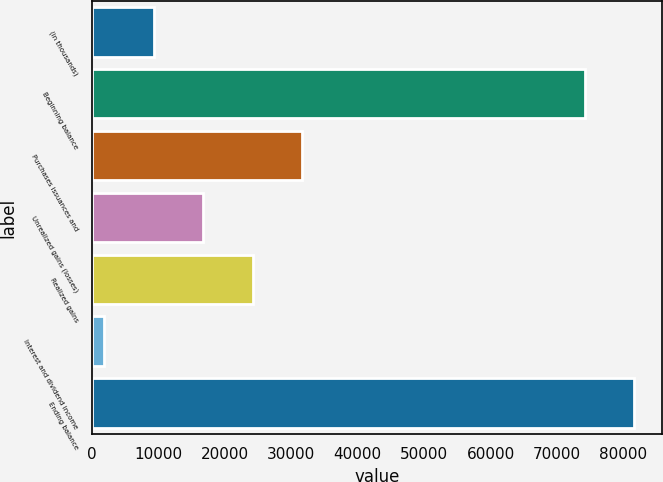Convert chart to OTSL. <chart><loc_0><loc_0><loc_500><loc_500><bar_chart><fcel>(in thousands)<fcel>Beginning balance<fcel>Purchases issuances and<fcel>Unrealized gains (losses)<fcel>Realized gains<fcel>Interest and dividend income<fcel>Ending balance<nl><fcel>9304.2<fcel>74204<fcel>31621.8<fcel>16743.4<fcel>24182.6<fcel>1865<fcel>81643.2<nl></chart> 